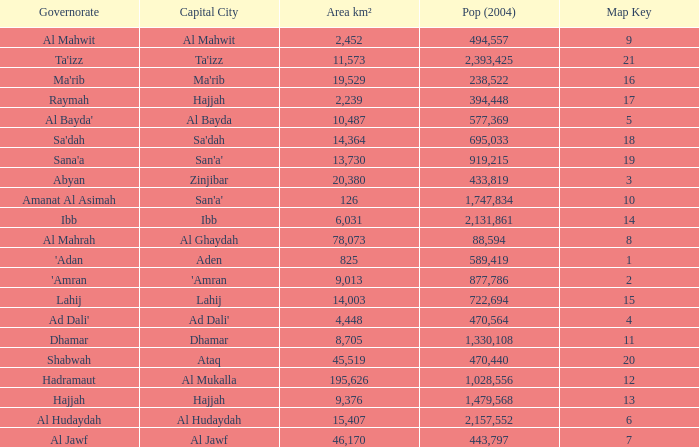How many Map Key has an Area km² larger than 14,003 and a Capital City of al mukalla, and a Pop (2004) larger than 1,028,556? None. 